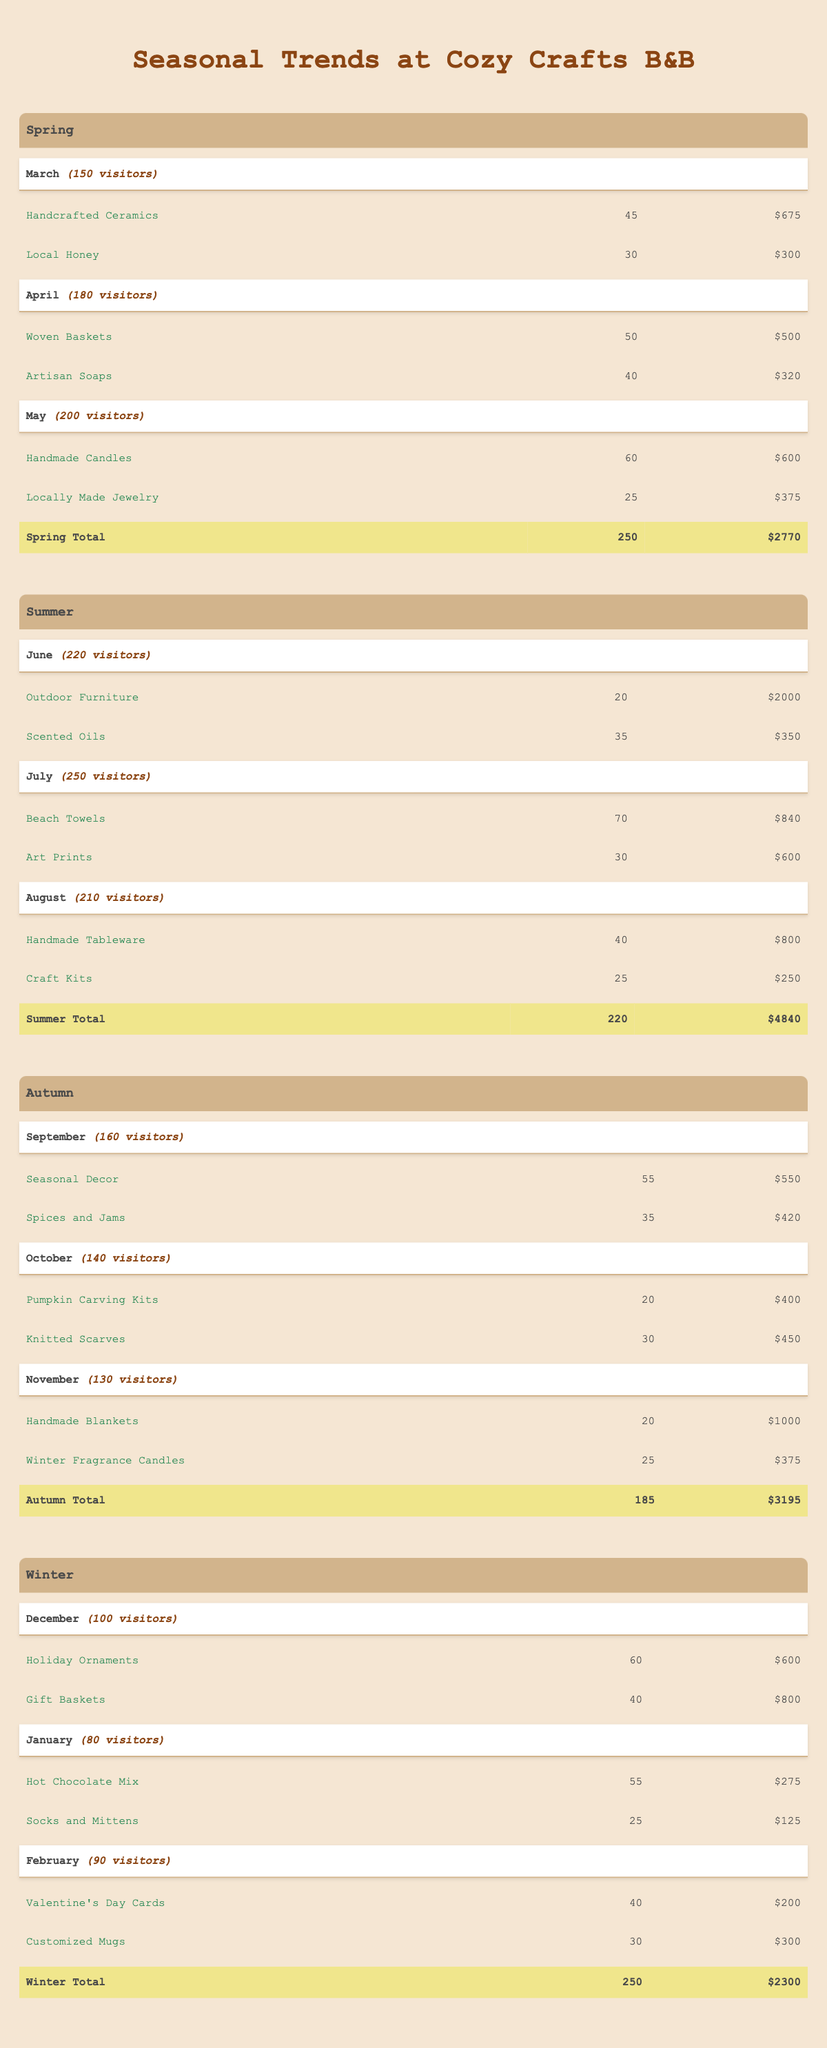What is the total revenue from the items sold in May? In May, the purchases were Handmade Candles with a revenue of 600 and Locally Made Jewelry with a revenue of 375. Adding these together gives 600 + 375 = 975.
Answer: 975 Which month in Autumn had the highest visitor count? Looking at the visitor counts for September (160), October (140), and November (130), September has the highest count at 160 visitors.
Answer: 160 What was the total quantity of purchases made in Summer? The quantities for Summer are: June (20 + 35), July (70 + 30), and August (40 + 25). Calculating those gives (20 + 35) + (70 + 30) + (40 + 25) = 55 + 100 + 65 = 220.
Answer: 220 Did visitor purchases in Winter generate more revenue than Autumn? Total revenue for Winter is 2300 (December: 600 + 800, January: 275 + 125, February: 200 + 300). Total revenue for Autumn is 3195. Comparing these figures, Winter's revenue is less than Autumn's revenue.
Answer: No What was the average visitor count for the entire year? Adding visitor counts: Spring (150 + 180 + 200 = 530), Summer (220 + 250 + 210 = 680), Autumn (160 + 140 + 130 = 430), Winter (100 + 80 + 90 = 270). This gives us a total of 530 + 680 + 430 + 270 = 1910 visitors over 12 months; thus, the average is 1910/12 = 159.17, rounded down gives 159.
Answer: 159 Which item generated the highest revenue in Summer? In Summer, the revenues are: June (2000 + 350), July (840 + 600), August (800 + 250). The highest revenue, 2000 from Outdoor Furniture in June, surpasses all others when compared.
Answer: 2000 What is the quantity difference of purchases between March and May? In March, the total quantity is 45 + 30 = 75, and in May it is 60 + 25 = 85. The difference is 85 - 75 = 10.
Answer: 10 How many more purchases were made in July than in January? In July, purchases total 70 + 30 = 100, and in January they are 55 + 25 = 80. The difference is 100 - 80 = 20.
Answer: 20 Which month in Spring had the least revenue from purchases? In March, revenue is 675 + 300 = 975, April is 500 + 320 = 820, and May is 600 + 375 = 975. The least revenue is from April at 820.
Answer: 820 